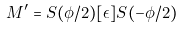Convert formula to latex. <formula><loc_0><loc_0><loc_500><loc_500>M ^ { \prime } = S ( \phi / 2 ) [ \epsilon ] S ( - \phi / 2 )</formula> 